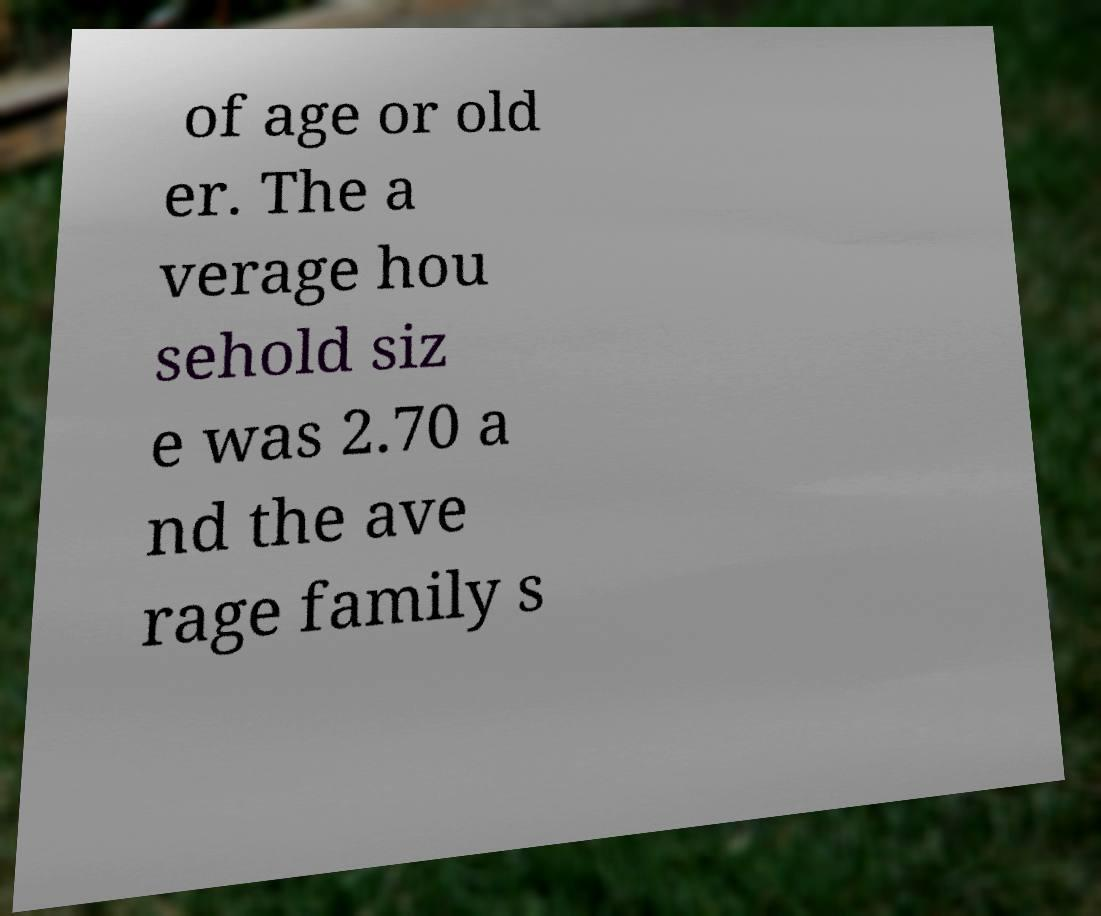Can you read and provide the text displayed in the image?This photo seems to have some interesting text. Can you extract and type it out for me? of age or old er. The a verage hou sehold siz e was 2.70 a nd the ave rage family s 